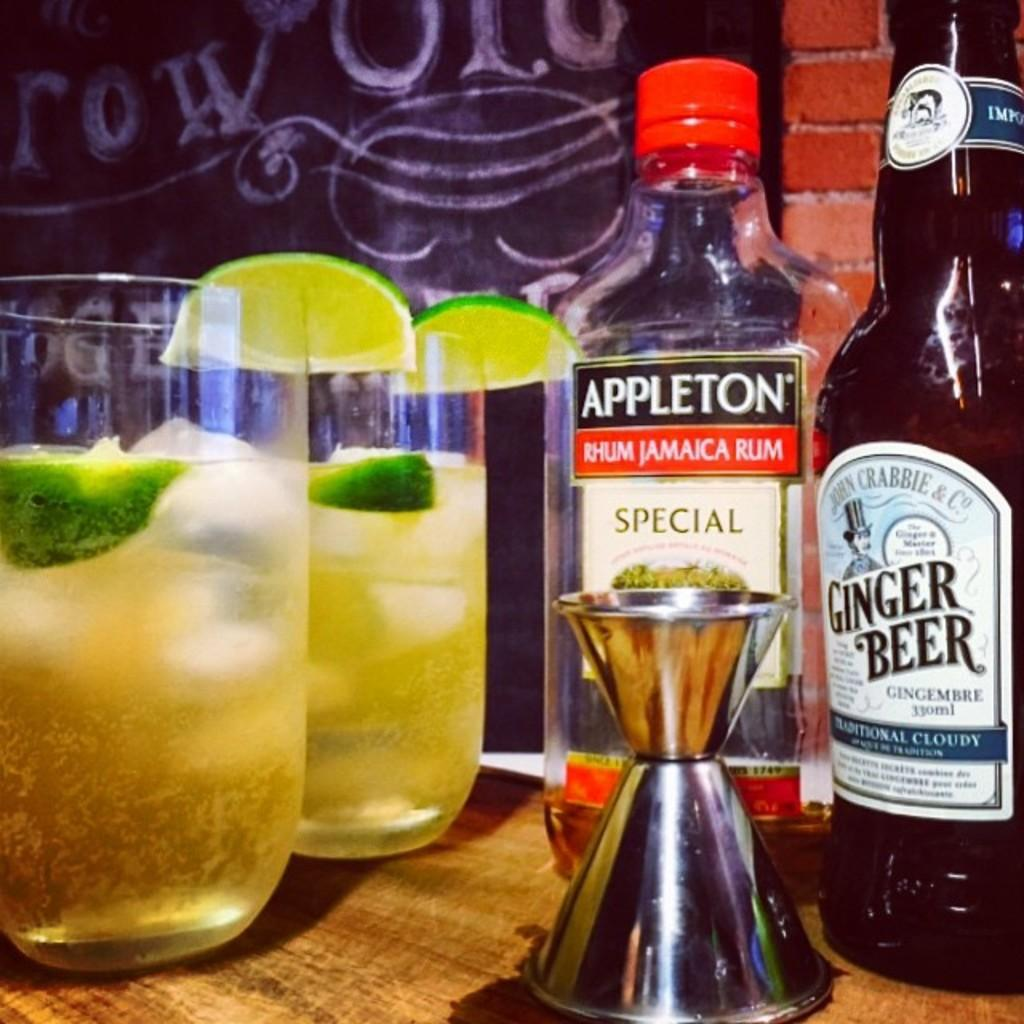<image>
Describe the image concisely. Two mixed drinks sitting in glass tumblers next to a bottle of Appleton Jamaican Rum and a bottle of Ginger Beer. 